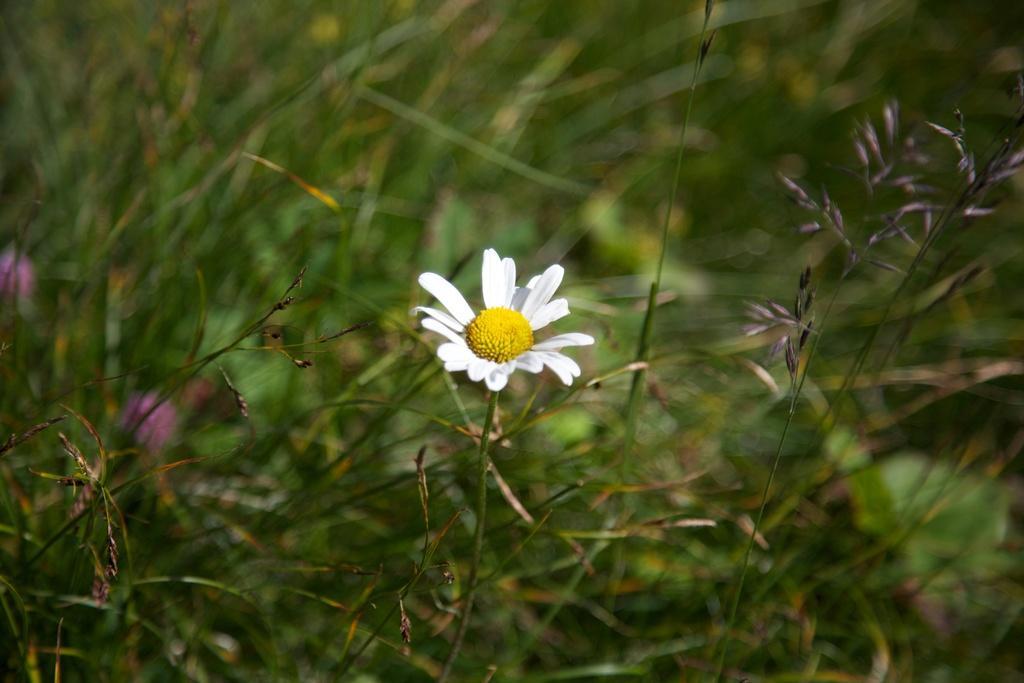Can you describe this image briefly? In this picture we can see a stem with a flower. In the background we can see plants and it is blurry. 